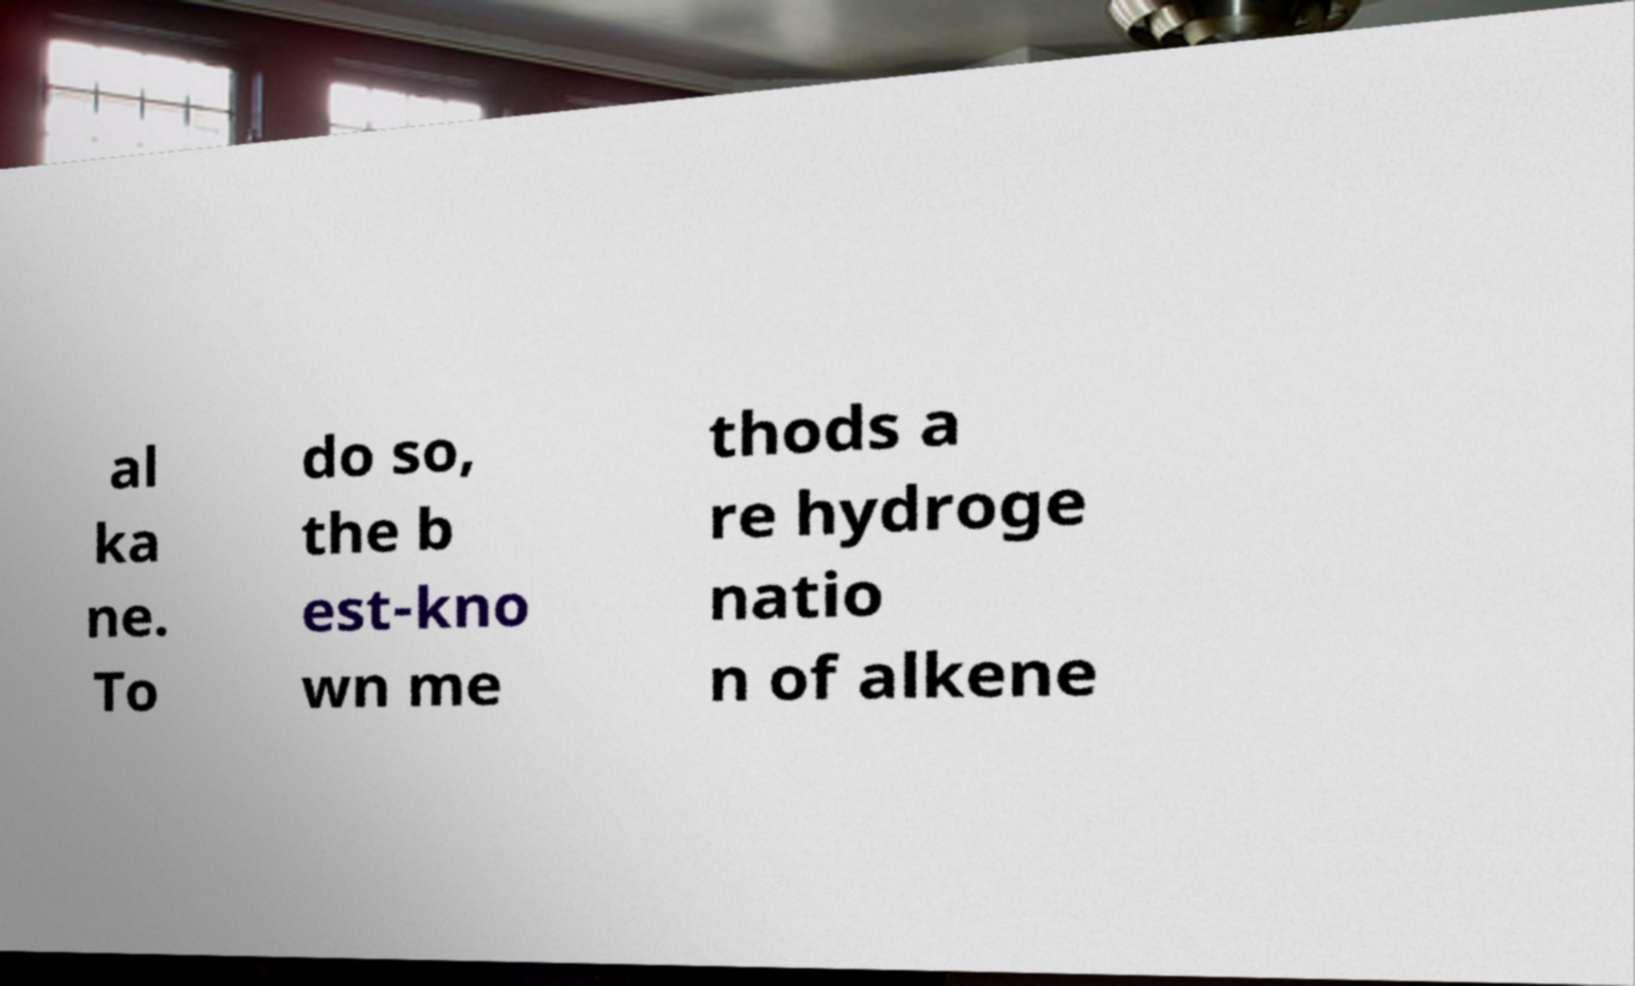Please read and relay the text visible in this image. What does it say? al ka ne. To do so, the b est-kno wn me thods a re hydroge natio n of alkene 